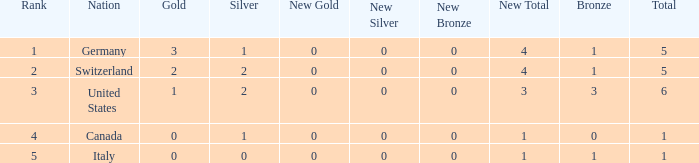How many golds for nations with over 0 silvers, over 1 total, and over 3 bronze? 0.0. 